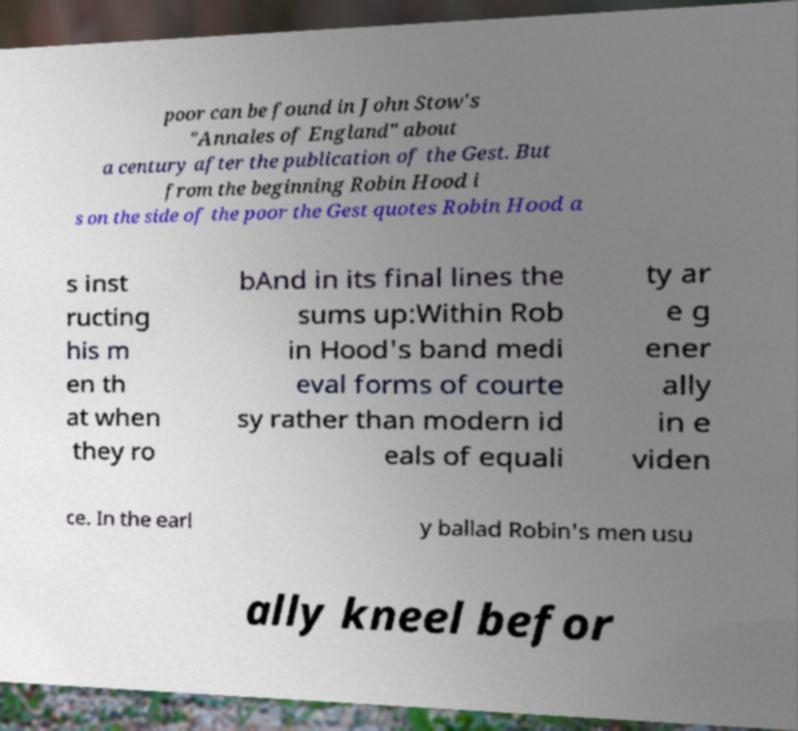There's text embedded in this image that I need extracted. Can you transcribe it verbatim? poor can be found in John Stow's "Annales of England" about a century after the publication of the Gest. But from the beginning Robin Hood i s on the side of the poor the Gest quotes Robin Hood a s inst ructing his m en th at when they ro bAnd in its final lines the sums up:Within Rob in Hood's band medi eval forms of courte sy rather than modern id eals of equali ty ar e g ener ally in e viden ce. In the earl y ballad Robin's men usu ally kneel befor 